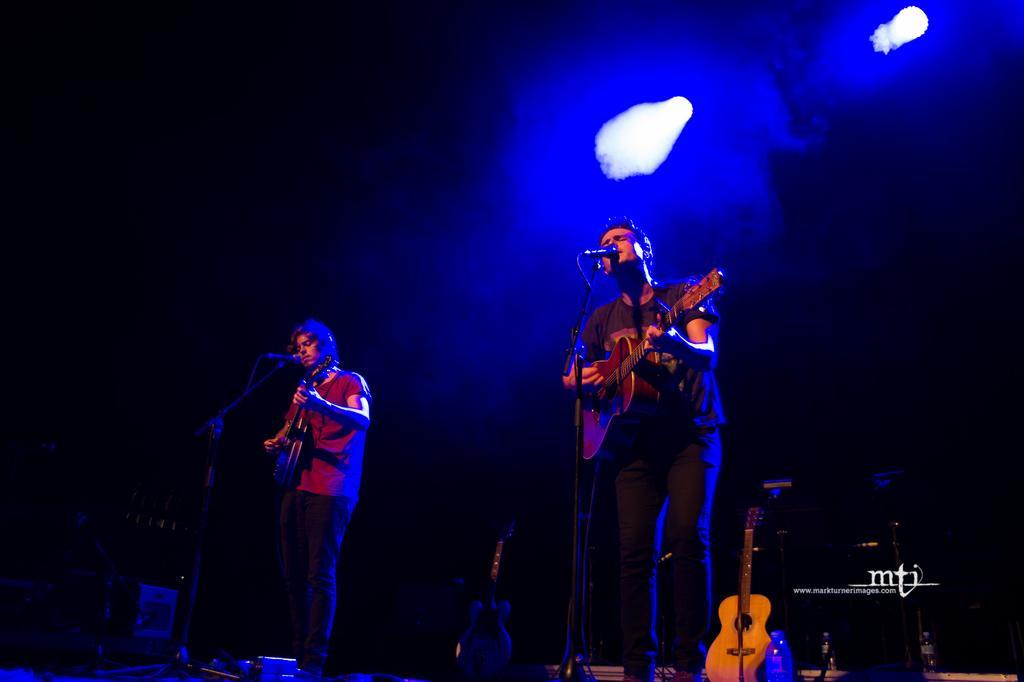Describe this image in one or two sentences. In this image there are two men who are playing the guitar and singing with the mic which is in front of them. At the top there are focus lights. 